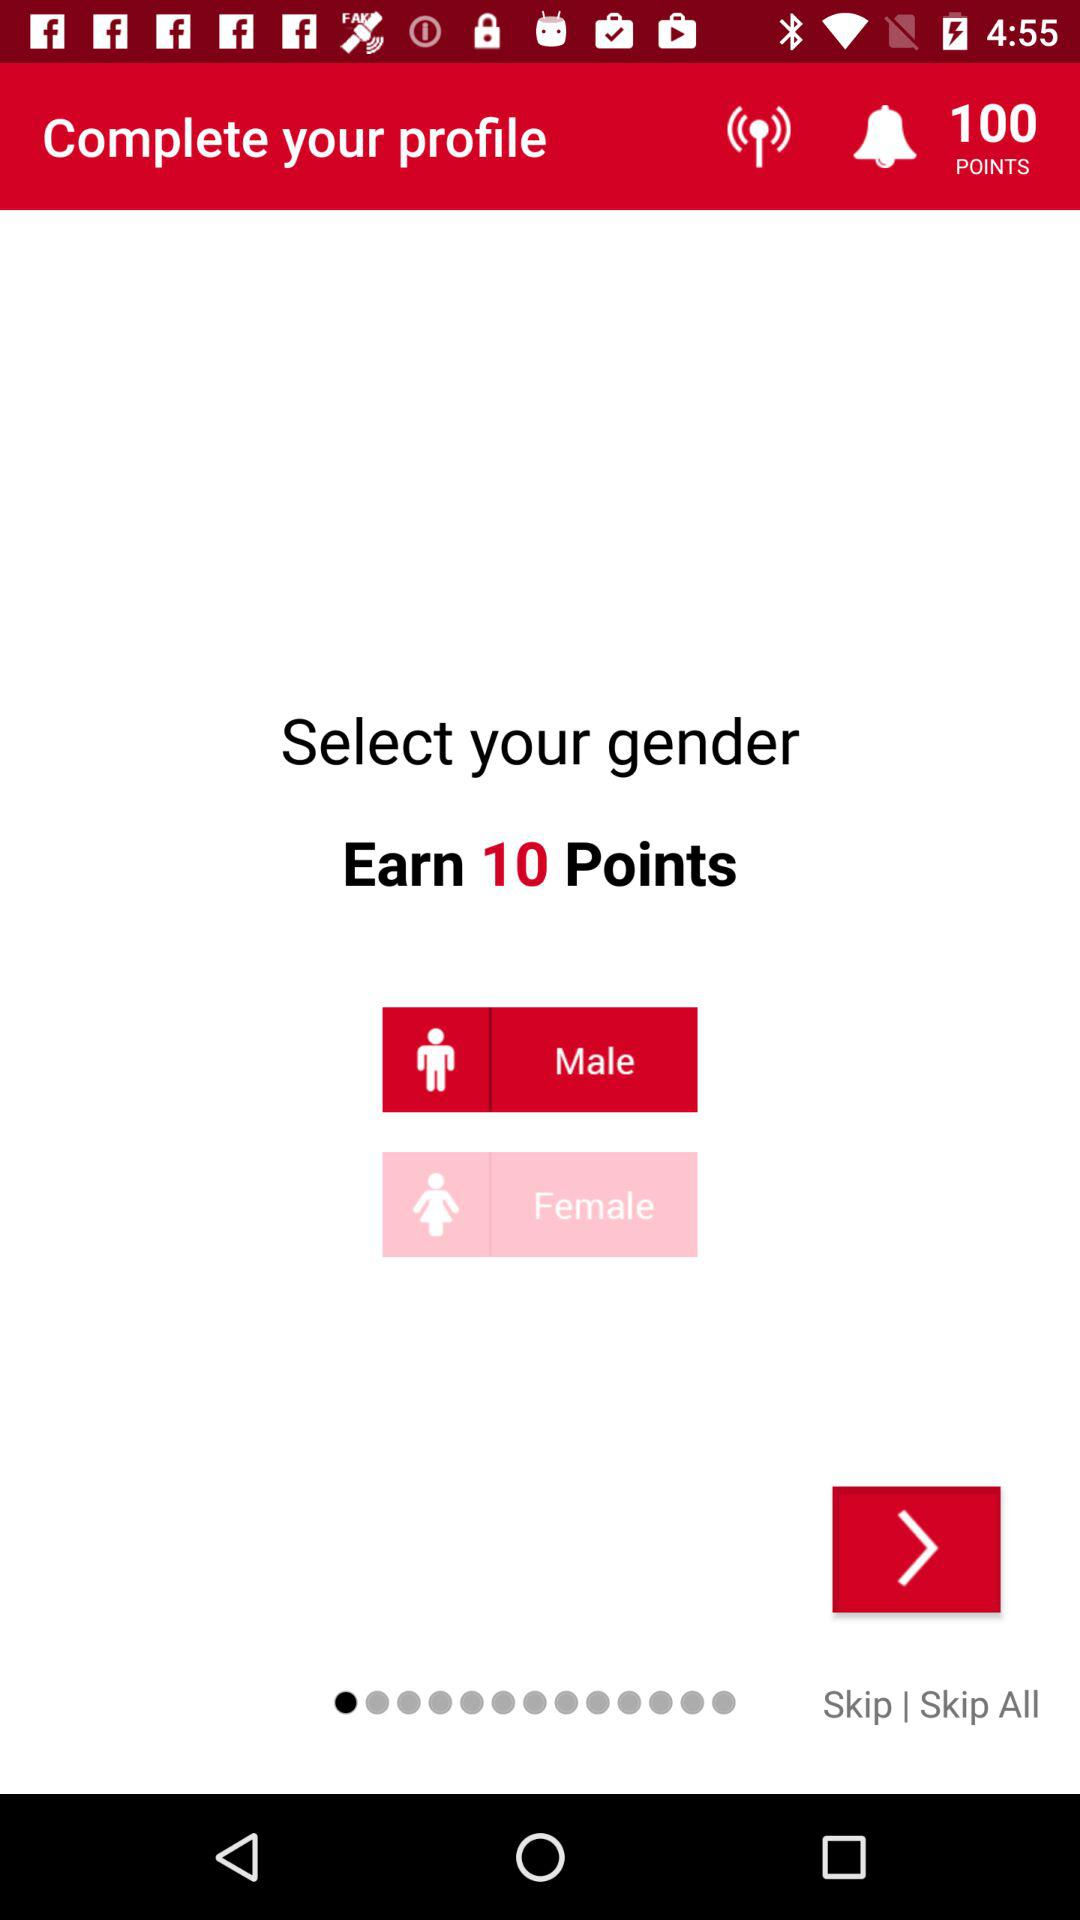How many total points are there? There are 10 points. 